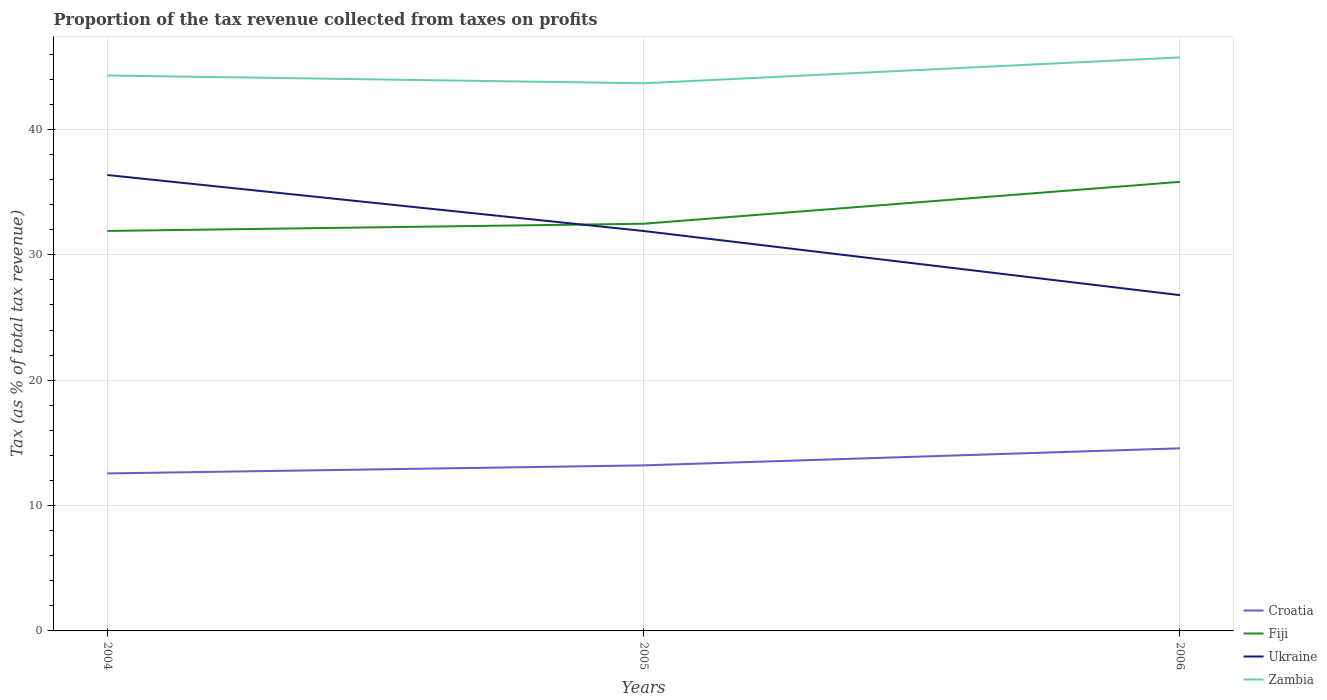How many different coloured lines are there?
Ensure brevity in your answer.  4. Does the line corresponding to Croatia intersect with the line corresponding to Fiji?
Give a very brief answer. No. Is the number of lines equal to the number of legend labels?
Provide a succinct answer. Yes. Across all years, what is the maximum proportion of the tax revenue collected in Croatia?
Your answer should be very brief. 12.56. In which year was the proportion of the tax revenue collected in Fiji maximum?
Ensure brevity in your answer.  2004. What is the total proportion of the tax revenue collected in Zambia in the graph?
Your answer should be compact. -2.07. What is the difference between the highest and the second highest proportion of the tax revenue collected in Croatia?
Provide a succinct answer. 2. What is the difference between the highest and the lowest proportion of the tax revenue collected in Fiji?
Your answer should be very brief. 1. Is the proportion of the tax revenue collected in Croatia strictly greater than the proportion of the tax revenue collected in Ukraine over the years?
Offer a very short reply. Yes. How many years are there in the graph?
Ensure brevity in your answer.  3. What is the difference between two consecutive major ticks on the Y-axis?
Your answer should be very brief. 10. Where does the legend appear in the graph?
Your response must be concise. Bottom right. How many legend labels are there?
Your answer should be very brief. 4. How are the legend labels stacked?
Your answer should be very brief. Vertical. What is the title of the graph?
Offer a terse response. Proportion of the tax revenue collected from taxes on profits. What is the label or title of the Y-axis?
Your answer should be very brief. Tax (as % of total tax revenue). What is the Tax (as % of total tax revenue) in Croatia in 2004?
Ensure brevity in your answer.  12.56. What is the Tax (as % of total tax revenue) in Fiji in 2004?
Your answer should be compact. 31.9. What is the Tax (as % of total tax revenue) of Ukraine in 2004?
Provide a short and direct response. 36.36. What is the Tax (as % of total tax revenue) of Zambia in 2004?
Provide a succinct answer. 44.3. What is the Tax (as % of total tax revenue) in Croatia in 2005?
Provide a succinct answer. 13.2. What is the Tax (as % of total tax revenue) of Fiji in 2005?
Make the answer very short. 32.48. What is the Tax (as % of total tax revenue) in Ukraine in 2005?
Make the answer very short. 31.9. What is the Tax (as % of total tax revenue) of Zambia in 2005?
Your answer should be compact. 43.68. What is the Tax (as % of total tax revenue) of Croatia in 2006?
Offer a very short reply. 14.56. What is the Tax (as % of total tax revenue) of Fiji in 2006?
Give a very brief answer. 35.82. What is the Tax (as % of total tax revenue) of Ukraine in 2006?
Your answer should be compact. 26.78. What is the Tax (as % of total tax revenue) in Zambia in 2006?
Make the answer very short. 45.74. Across all years, what is the maximum Tax (as % of total tax revenue) of Croatia?
Offer a very short reply. 14.56. Across all years, what is the maximum Tax (as % of total tax revenue) of Fiji?
Your response must be concise. 35.82. Across all years, what is the maximum Tax (as % of total tax revenue) of Ukraine?
Offer a very short reply. 36.36. Across all years, what is the maximum Tax (as % of total tax revenue) of Zambia?
Your answer should be compact. 45.74. Across all years, what is the minimum Tax (as % of total tax revenue) of Croatia?
Make the answer very short. 12.56. Across all years, what is the minimum Tax (as % of total tax revenue) in Fiji?
Make the answer very short. 31.9. Across all years, what is the minimum Tax (as % of total tax revenue) in Ukraine?
Keep it short and to the point. 26.78. Across all years, what is the minimum Tax (as % of total tax revenue) in Zambia?
Provide a succinct answer. 43.68. What is the total Tax (as % of total tax revenue) in Croatia in the graph?
Make the answer very short. 40.33. What is the total Tax (as % of total tax revenue) in Fiji in the graph?
Provide a succinct answer. 100.19. What is the total Tax (as % of total tax revenue) of Ukraine in the graph?
Make the answer very short. 95.04. What is the total Tax (as % of total tax revenue) in Zambia in the graph?
Your answer should be very brief. 133.72. What is the difference between the Tax (as % of total tax revenue) of Croatia in 2004 and that in 2005?
Keep it short and to the point. -0.64. What is the difference between the Tax (as % of total tax revenue) of Fiji in 2004 and that in 2005?
Your answer should be very brief. -0.57. What is the difference between the Tax (as % of total tax revenue) in Ukraine in 2004 and that in 2005?
Your answer should be compact. 4.47. What is the difference between the Tax (as % of total tax revenue) of Zambia in 2004 and that in 2005?
Your response must be concise. 0.62. What is the difference between the Tax (as % of total tax revenue) of Croatia in 2004 and that in 2006?
Provide a succinct answer. -2. What is the difference between the Tax (as % of total tax revenue) of Fiji in 2004 and that in 2006?
Make the answer very short. -3.91. What is the difference between the Tax (as % of total tax revenue) of Ukraine in 2004 and that in 2006?
Your response must be concise. 9.58. What is the difference between the Tax (as % of total tax revenue) of Zambia in 2004 and that in 2006?
Keep it short and to the point. -1.44. What is the difference between the Tax (as % of total tax revenue) in Croatia in 2005 and that in 2006?
Provide a short and direct response. -1.36. What is the difference between the Tax (as % of total tax revenue) in Fiji in 2005 and that in 2006?
Your answer should be compact. -3.34. What is the difference between the Tax (as % of total tax revenue) in Ukraine in 2005 and that in 2006?
Your answer should be very brief. 5.12. What is the difference between the Tax (as % of total tax revenue) in Zambia in 2005 and that in 2006?
Offer a terse response. -2.07. What is the difference between the Tax (as % of total tax revenue) of Croatia in 2004 and the Tax (as % of total tax revenue) of Fiji in 2005?
Make the answer very short. -19.91. What is the difference between the Tax (as % of total tax revenue) in Croatia in 2004 and the Tax (as % of total tax revenue) in Ukraine in 2005?
Your answer should be compact. -19.34. What is the difference between the Tax (as % of total tax revenue) of Croatia in 2004 and the Tax (as % of total tax revenue) of Zambia in 2005?
Give a very brief answer. -31.12. What is the difference between the Tax (as % of total tax revenue) of Fiji in 2004 and the Tax (as % of total tax revenue) of Ukraine in 2005?
Your answer should be very brief. 0.01. What is the difference between the Tax (as % of total tax revenue) in Fiji in 2004 and the Tax (as % of total tax revenue) in Zambia in 2005?
Your answer should be very brief. -11.77. What is the difference between the Tax (as % of total tax revenue) in Ukraine in 2004 and the Tax (as % of total tax revenue) in Zambia in 2005?
Provide a short and direct response. -7.31. What is the difference between the Tax (as % of total tax revenue) of Croatia in 2004 and the Tax (as % of total tax revenue) of Fiji in 2006?
Ensure brevity in your answer.  -23.26. What is the difference between the Tax (as % of total tax revenue) in Croatia in 2004 and the Tax (as % of total tax revenue) in Ukraine in 2006?
Provide a short and direct response. -14.22. What is the difference between the Tax (as % of total tax revenue) in Croatia in 2004 and the Tax (as % of total tax revenue) in Zambia in 2006?
Make the answer very short. -33.18. What is the difference between the Tax (as % of total tax revenue) in Fiji in 2004 and the Tax (as % of total tax revenue) in Ukraine in 2006?
Your answer should be compact. 5.12. What is the difference between the Tax (as % of total tax revenue) in Fiji in 2004 and the Tax (as % of total tax revenue) in Zambia in 2006?
Your response must be concise. -13.84. What is the difference between the Tax (as % of total tax revenue) in Ukraine in 2004 and the Tax (as % of total tax revenue) in Zambia in 2006?
Your response must be concise. -9.38. What is the difference between the Tax (as % of total tax revenue) of Croatia in 2005 and the Tax (as % of total tax revenue) of Fiji in 2006?
Your answer should be compact. -22.61. What is the difference between the Tax (as % of total tax revenue) of Croatia in 2005 and the Tax (as % of total tax revenue) of Ukraine in 2006?
Provide a succinct answer. -13.58. What is the difference between the Tax (as % of total tax revenue) of Croatia in 2005 and the Tax (as % of total tax revenue) of Zambia in 2006?
Offer a very short reply. -32.54. What is the difference between the Tax (as % of total tax revenue) in Fiji in 2005 and the Tax (as % of total tax revenue) in Ukraine in 2006?
Provide a short and direct response. 5.7. What is the difference between the Tax (as % of total tax revenue) of Fiji in 2005 and the Tax (as % of total tax revenue) of Zambia in 2006?
Offer a terse response. -13.27. What is the difference between the Tax (as % of total tax revenue) in Ukraine in 2005 and the Tax (as % of total tax revenue) in Zambia in 2006?
Your answer should be very brief. -13.85. What is the average Tax (as % of total tax revenue) of Croatia per year?
Offer a very short reply. 13.44. What is the average Tax (as % of total tax revenue) in Fiji per year?
Provide a succinct answer. 33.4. What is the average Tax (as % of total tax revenue) in Ukraine per year?
Give a very brief answer. 31.68. What is the average Tax (as % of total tax revenue) of Zambia per year?
Offer a very short reply. 44.57. In the year 2004, what is the difference between the Tax (as % of total tax revenue) of Croatia and Tax (as % of total tax revenue) of Fiji?
Offer a very short reply. -19.34. In the year 2004, what is the difference between the Tax (as % of total tax revenue) of Croatia and Tax (as % of total tax revenue) of Ukraine?
Ensure brevity in your answer.  -23.8. In the year 2004, what is the difference between the Tax (as % of total tax revenue) of Croatia and Tax (as % of total tax revenue) of Zambia?
Your response must be concise. -31.74. In the year 2004, what is the difference between the Tax (as % of total tax revenue) in Fiji and Tax (as % of total tax revenue) in Ukraine?
Give a very brief answer. -4.46. In the year 2004, what is the difference between the Tax (as % of total tax revenue) of Fiji and Tax (as % of total tax revenue) of Zambia?
Your answer should be compact. -12.4. In the year 2004, what is the difference between the Tax (as % of total tax revenue) in Ukraine and Tax (as % of total tax revenue) in Zambia?
Your response must be concise. -7.94. In the year 2005, what is the difference between the Tax (as % of total tax revenue) in Croatia and Tax (as % of total tax revenue) in Fiji?
Provide a short and direct response. -19.27. In the year 2005, what is the difference between the Tax (as % of total tax revenue) of Croatia and Tax (as % of total tax revenue) of Ukraine?
Ensure brevity in your answer.  -18.69. In the year 2005, what is the difference between the Tax (as % of total tax revenue) in Croatia and Tax (as % of total tax revenue) in Zambia?
Give a very brief answer. -30.47. In the year 2005, what is the difference between the Tax (as % of total tax revenue) in Fiji and Tax (as % of total tax revenue) in Ukraine?
Provide a short and direct response. 0.58. In the year 2005, what is the difference between the Tax (as % of total tax revenue) of Fiji and Tax (as % of total tax revenue) of Zambia?
Keep it short and to the point. -11.2. In the year 2005, what is the difference between the Tax (as % of total tax revenue) in Ukraine and Tax (as % of total tax revenue) in Zambia?
Your answer should be compact. -11.78. In the year 2006, what is the difference between the Tax (as % of total tax revenue) in Croatia and Tax (as % of total tax revenue) in Fiji?
Your answer should be very brief. -21.25. In the year 2006, what is the difference between the Tax (as % of total tax revenue) of Croatia and Tax (as % of total tax revenue) of Ukraine?
Your response must be concise. -12.22. In the year 2006, what is the difference between the Tax (as % of total tax revenue) in Croatia and Tax (as % of total tax revenue) in Zambia?
Your answer should be very brief. -31.18. In the year 2006, what is the difference between the Tax (as % of total tax revenue) of Fiji and Tax (as % of total tax revenue) of Ukraine?
Provide a succinct answer. 9.04. In the year 2006, what is the difference between the Tax (as % of total tax revenue) of Fiji and Tax (as % of total tax revenue) of Zambia?
Your answer should be very brief. -9.93. In the year 2006, what is the difference between the Tax (as % of total tax revenue) of Ukraine and Tax (as % of total tax revenue) of Zambia?
Provide a short and direct response. -18.96. What is the ratio of the Tax (as % of total tax revenue) of Croatia in 2004 to that in 2005?
Give a very brief answer. 0.95. What is the ratio of the Tax (as % of total tax revenue) of Fiji in 2004 to that in 2005?
Offer a very short reply. 0.98. What is the ratio of the Tax (as % of total tax revenue) in Ukraine in 2004 to that in 2005?
Your response must be concise. 1.14. What is the ratio of the Tax (as % of total tax revenue) of Zambia in 2004 to that in 2005?
Your answer should be compact. 1.01. What is the ratio of the Tax (as % of total tax revenue) of Croatia in 2004 to that in 2006?
Offer a terse response. 0.86. What is the ratio of the Tax (as % of total tax revenue) of Fiji in 2004 to that in 2006?
Your answer should be compact. 0.89. What is the ratio of the Tax (as % of total tax revenue) in Ukraine in 2004 to that in 2006?
Give a very brief answer. 1.36. What is the ratio of the Tax (as % of total tax revenue) in Zambia in 2004 to that in 2006?
Make the answer very short. 0.97. What is the ratio of the Tax (as % of total tax revenue) in Croatia in 2005 to that in 2006?
Your answer should be very brief. 0.91. What is the ratio of the Tax (as % of total tax revenue) in Fiji in 2005 to that in 2006?
Your answer should be compact. 0.91. What is the ratio of the Tax (as % of total tax revenue) of Ukraine in 2005 to that in 2006?
Offer a terse response. 1.19. What is the ratio of the Tax (as % of total tax revenue) of Zambia in 2005 to that in 2006?
Keep it short and to the point. 0.95. What is the difference between the highest and the second highest Tax (as % of total tax revenue) of Croatia?
Offer a terse response. 1.36. What is the difference between the highest and the second highest Tax (as % of total tax revenue) of Fiji?
Offer a terse response. 3.34. What is the difference between the highest and the second highest Tax (as % of total tax revenue) in Ukraine?
Provide a succinct answer. 4.47. What is the difference between the highest and the second highest Tax (as % of total tax revenue) of Zambia?
Keep it short and to the point. 1.44. What is the difference between the highest and the lowest Tax (as % of total tax revenue) in Croatia?
Give a very brief answer. 2. What is the difference between the highest and the lowest Tax (as % of total tax revenue) in Fiji?
Make the answer very short. 3.91. What is the difference between the highest and the lowest Tax (as % of total tax revenue) of Ukraine?
Your answer should be compact. 9.58. What is the difference between the highest and the lowest Tax (as % of total tax revenue) in Zambia?
Ensure brevity in your answer.  2.07. 